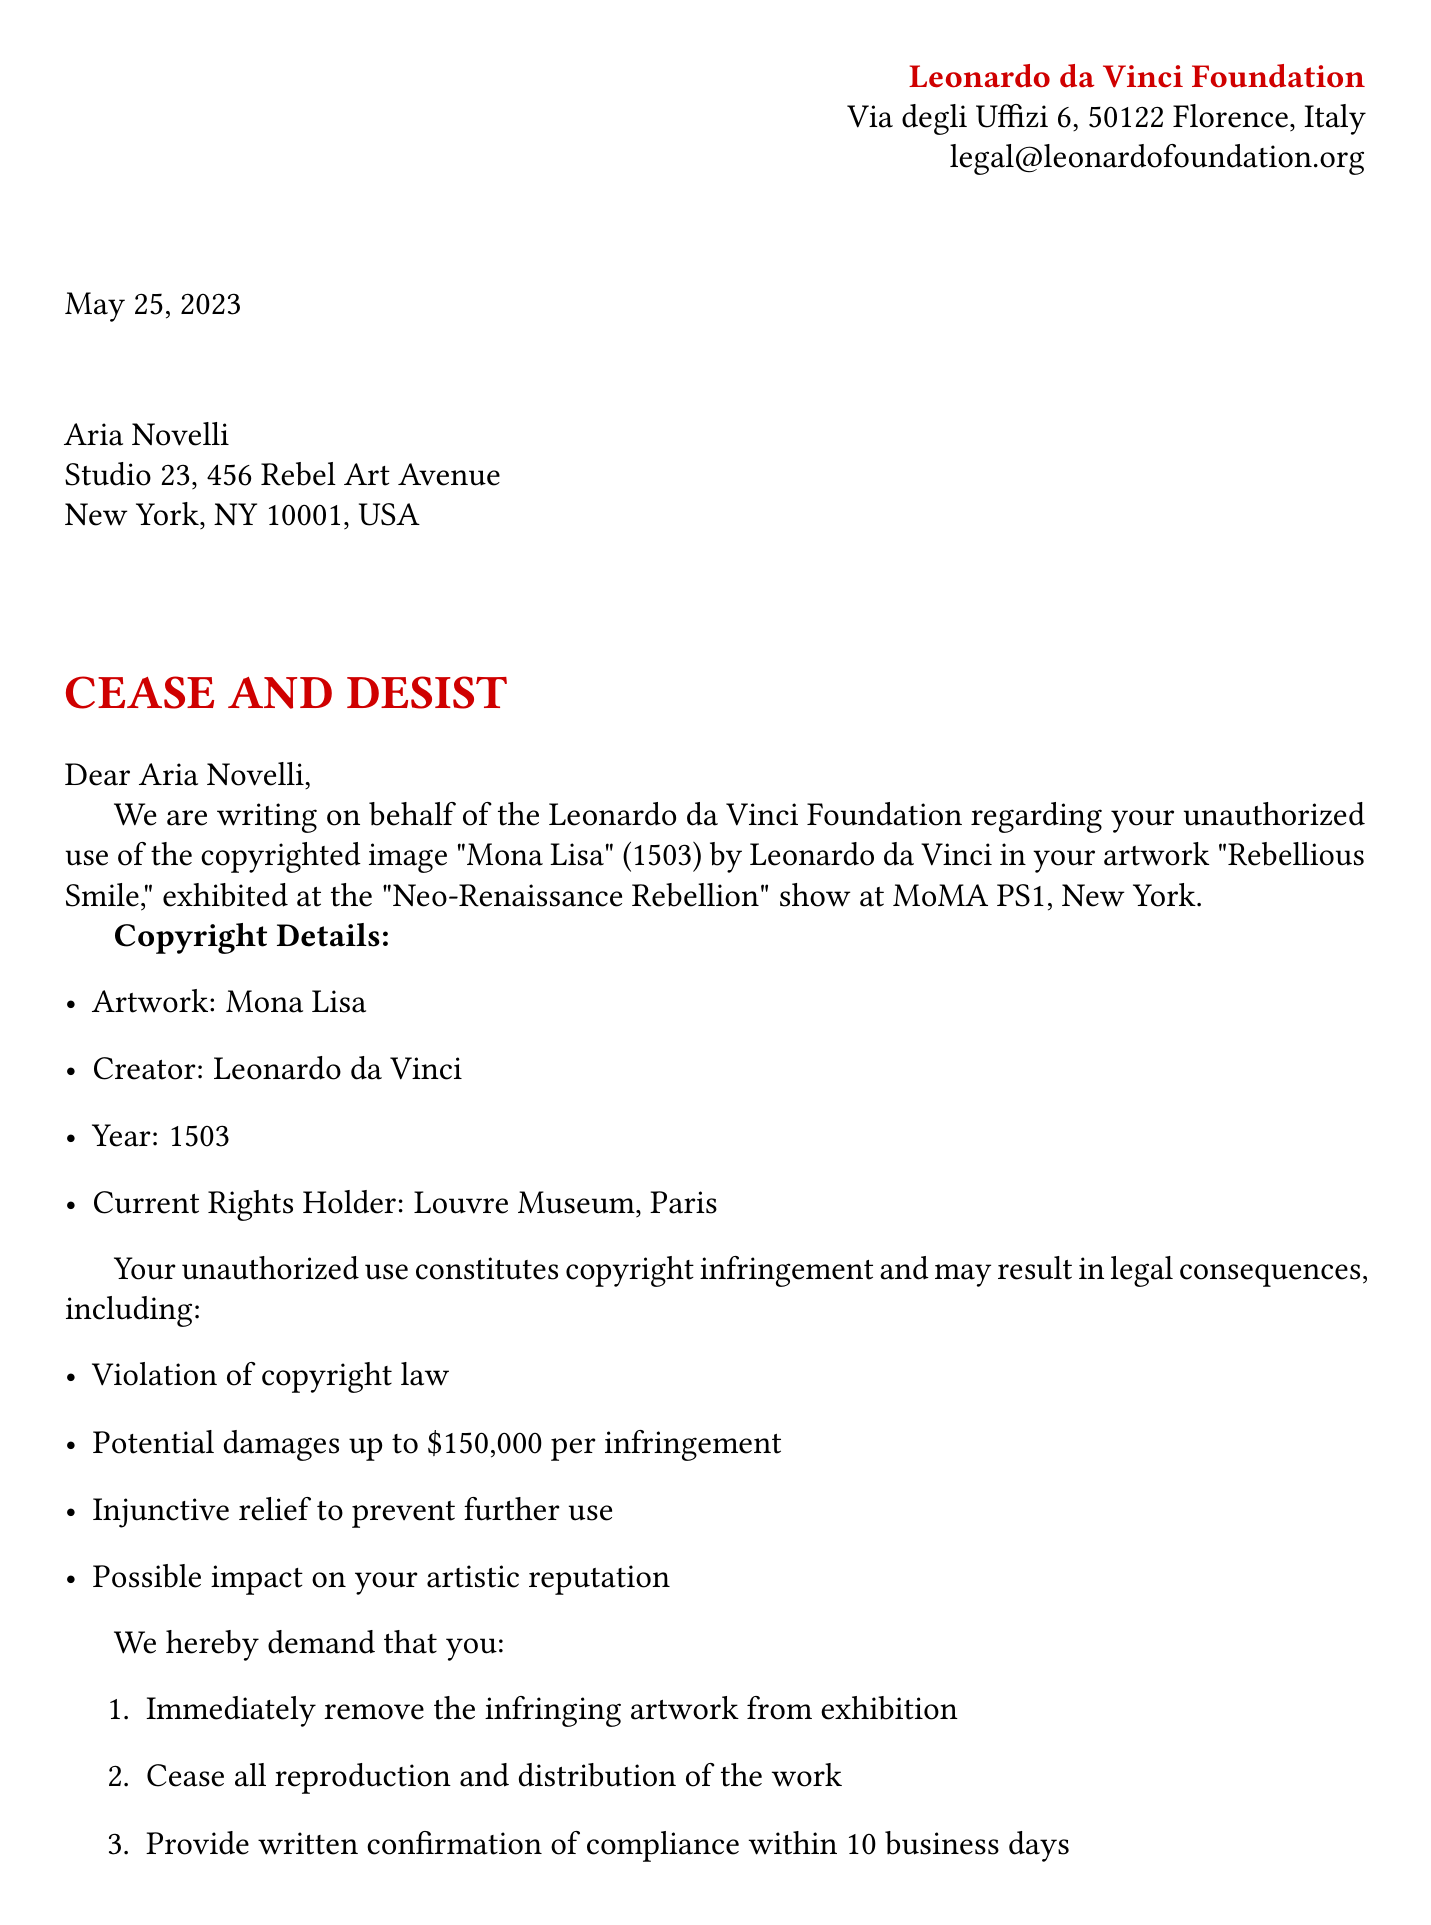What is the name of the sender? The sender's name is indicated at the top of the document as the Leonardo da Vinci Foundation.
Answer: Leonardo da Vinci Foundation What year was the Mona Lisa created? The document specifies that the year of creation for the Mona Lisa is 1503.
Answer: 1503 What is the maximum potential damages per infringement? The document states that potential damages could be up to $150,000 per infringement, which is explicitly listed in the legal implications section.
Answer: $150,000 What action is requested regarding the infringing artwork? The document lists multiple actions, including the immediate removal of the artwork from exhibition, which is the first requested action.
Answer: Remove the infringing artwork What does the foundation assert about fair use? The document indicates that while artistic interpretation is appreciated, the extent of use exceeds the fair use doctrine, pointing to the foundation's view on the legality of the usage.
Answer: Exceeds fair use doctrine What gallery hosted the exhibition Neo-Renaissance Rebellion? The document specifies the gallery where the exhibition took place, which is MoMA PS1 in New York.
Answer: MoMA PS1 What is the deadline for providing written confirmation of compliance? According to the document, written confirmation of compliance must be provided within 10 business days.
Answer: 10 business days What does the foundation emphasize about attribution? The document emphasizes that proper attribution is crucial in maintaining the integrity of Renaissance masterpieces.
Answer: Proper attribution is crucial 